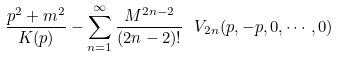Convert formula to latex. <formula><loc_0><loc_0><loc_500><loc_500>\frac { p ^ { 2 } + m ^ { 2 } } { K ( p ) } - \sum _ { n = 1 } ^ { \infty } \frac { M ^ { 2 n - 2 } } { ( 2 n - 2 ) ! } \ V _ { 2 n } ( p , - p , 0 , \cdots , 0 )</formula> 